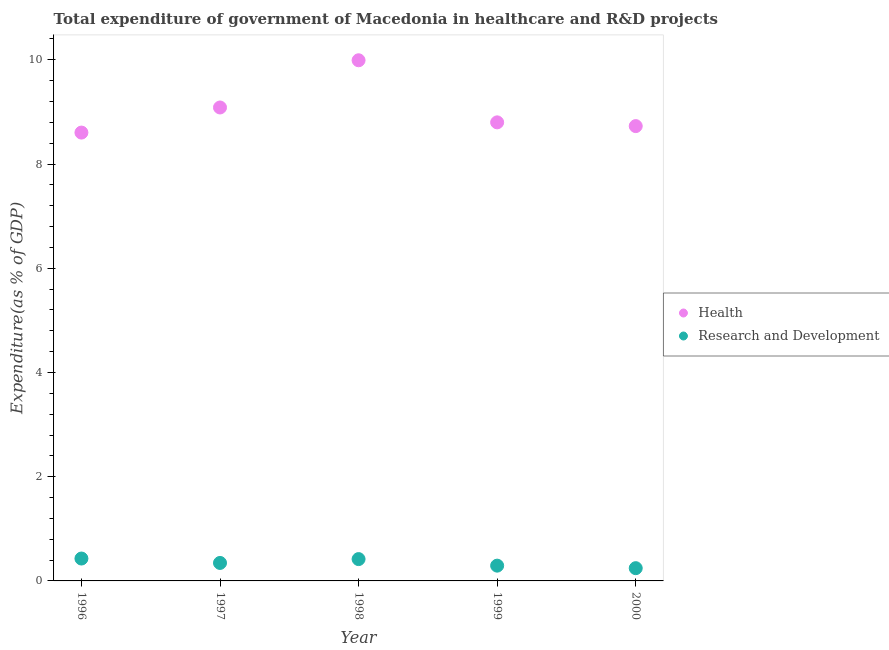How many different coloured dotlines are there?
Your answer should be compact. 2. What is the expenditure in r&d in 1999?
Give a very brief answer. 0.29. Across all years, what is the maximum expenditure in healthcare?
Your answer should be very brief. 9.99. Across all years, what is the minimum expenditure in healthcare?
Keep it short and to the point. 8.6. In which year was the expenditure in healthcare maximum?
Give a very brief answer. 1998. In which year was the expenditure in r&d minimum?
Make the answer very short. 2000. What is the total expenditure in healthcare in the graph?
Offer a terse response. 45.21. What is the difference between the expenditure in healthcare in 1997 and that in 1999?
Your response must be concise. 0.29. What is the difference between the expenditure in healthcare in 1997 and the expenditure in r&d in 1996?
Your answer should be compact. 8.66. What is the average expenditure in r&d per year?
Ensure brevity in your answer.  0.35. In the year 1996, what is the difference between the expenditure in healthcare and expenditure in r&d?
Offer a terse response. 8.17. What is the ratio of the expenditure in healthcare in 1997 to that in 1999?
Ensure brevity in your answer.  1.03. What is the difference between the highest and the second highest expenditure in r&d?
Make the answer very short. 0.01. What is the difference between the highest and the lowest expenditure in r&d?
Your answer should be compact. 0.18. In how many years, is the expenditure in r&d greater than the average expenditure in r&d taken over all years?
Your response must be concise. 2. Is the sum of the expenditure in healthcare in 1997 and 1998 greater than the maximum expenditure in r&d across all years?
Your response must be concise. Yes. Does the expenditure in r&d monotonically increase over the years?
Ensure brevity in your answer.  No. Is the expenditure in r&d strictly less than the expenditure in healthcare over the years?
Make the answer very short. Yes. How many dotlines are there?
Make the answer very short. 2. What is the difference between two consecutive major ticks on the Y-axis?
Give a very brief answer. 2. Does the graph contain any zero values?
Your answer should be very brief. No. Does the graph contain grids?
Ensure brevity in your answer.  No. How many legend labels are there?
Make the answer very short. 2. What is the title of the graph?
Keep it short and to the point. Total expenditure of government of Macedonia in healthcare and R&D projects. Does "Male entrants" appear as one of the legend labels in the graph?
Offer a terse response. No. What is the label or title of the X-axis?
Provide a short and direct response. Year. What is the label or title of the Y-axis?
Your answer should be compact. Expenditure(as % of GDP). What is the Expenditure(as % of GDP) of Health in 1996?
Your response must be concise. 8.6. What is the Expenditure(as % of GDP) in Research and Development in 1996?
Ensure brevity in your answer.  0.43. What is the Expenditure(as % of GDP) of Health in 1997?
Your answer should be very brief. 9.09. What is the Expenditure(as % of GDP) in Research and Development in 1997?
Provide a succinct answer. 0.35. What is the Expenditure(as % of GDP) of Health in 1998?
Ensure brevity in your answer.  9.99. What is the Expenditure(as % of GDP) in Research and Development in 1998?
Keep it short and to the point. 0.42. What is the Expenditure(as % of GDP) in Health in 1999?
Your answer should be very brief. 8.8. What is the Expenditure(as % of GDP) in Research and Development in 1999?
Your answer should be compact. 0.29. What is the Expenditure(as % of GDP) in Health in 2000?
Provide a succinct answer. 8.73. What is the Expenditure(as % of GDP) in Research and Development in 2000?
Ensure brevity in your answer.  0.24. Across all years, what is the maximum Expenditure(as % of GDP) of Health?
Give a very brief answer. 9.99. Across all years, what is the maximum Expenditure(as % of GDP) in Research and Development?
Offer a very short reply. 0.43. Across all years, what is the minimum Expenditure(as % of GDP) in Health?
Your answer should be very brief. 8.6. Across all years, what is the minimum Expenditure(as % of GDP) of Research and Development?
Give a very brief answer. 0.24. What is the total Expenditure(as % of GDP) in Health in the graph?
Keep it short and to the point. 45.21. What is the total Expenditure(as % of GDP) of Research and Development in the graph?
Give a very brief answer. 1.73. What is the difference between the Expenditure(as % of GDP) of Health in 1996 and that in 1997?
Make the answer very short. -0.48. What is the difference between the Expenditure(as % of GDP) in Research and Development in 1996 and that in 1997?
Ensure brevity in your answer.  0.08. What is the difference between the Expenditure(as % of GDP) in Health in 1996 and that in 1998?
Offer a terse response. -1.39. What is the difference between the Expenditure(as % of GDP) of Research and Development in 1996 and that in 1998?
Provide a short and direct response. 0.01. What is the difference between the Expenditure(as % of GDP) in Health in 1996 and that in 1999?
Offer a terse response. -0.2. What is the difference between the Expenditure(as % of GDP) of Research and Development in 1996 and that in 1999?
Your answer should be compact. 0.14. What is the difference between the Expenditure(as % of GDP) of Health in 1996 and that in 2000?
Provide a succinct answer. -0.12. What is the difference between the Expenditure(as % of GDP) of Research and Development in 1996 and that in 2000?
Offer a terse response. 0.18. What is the difference between the Expenditure(as % of GDP) of Health in 1997 and that in 1998?
Give a very brief answer. -0.91. What is the difference between the Expenditure(as % of GDP) of Research and Development in 1997 and that in 1998?
Keep it short and to the point. -0.07. What is the difference between the Expenditure(as % of GDP) of Health in 1997 and that in 1999?
Your response must be concise. 0.29. What is the difference between the Expenditure(as % of GDP) of Research and Development in 1997 and that in 1999?
Offer a very short reply. 0.05. What is the difference between the Expenditure(as % of GDP) in Health in 1997 and that in 2000?
Offer a terse response. 0.36. What is the difference between the Expenditure(as % of GDP) in Research and Development in 1997 and that in 2000?
Your answer should be very brief. 0.1. What is the difference between the Expenditure(as % of GDP) of Health in 1998 and that in 1999?
Keep it short and to the point. 1.19. What is the difference between the Expenditure(as % of GDP) of Research and Development in 1998 and that in 1999?
Provide a succinct answer. 0.13. What is the difference between the Expenditure(as % of GDP) of Health in 1998 and that in 2000?
Your response must be concise. 1.26. What is the difference between the Expenditure(as % of GDP) of Research and Development in 1998 and that in 2000?
Give a very brief answer. 0.17. What is the difference between the Expenditure(as % of GDP) of Health in 1999 and that in 2000?
Offer a very short reply. 0.07. What is the difference between the Expenditure(as % of GDP) of Research and Development in 1999 and that in 2000?
Make the answer very short. 0.05. What is the difference between the Expenditure(as % of GDP) in Health in 1996 and the Expenditure(as % of GDP) in Research and Development in 1997?
Offer a terse response. 8.26. What is the difference between the Expenditure(as % of GDP) in Health in 1996 and the Expenditure(as % of GDP) in Research and Development in 1998?
Ensure brevity in your answer.  8.18. What is the difference between the Expenditure(as % of GDP) of Health in 1996 and the Expenditure(as % of GDP) of Research and Development in 1999?
Your response must be concise. 8.31. What is the difference between the Expenditure(as % of GDP) in Health in 1996 and the Expenditure(as % of GDP) in Research and Development in 2000?
Give a very brief answer. 8.36. What is the difference between the Expenditure(as % of GDP) in Health in 1997 and the Expenditure(as % of GDP) in Research and Development in 1998?
Offer a very short reply. 8.67. What is the difference between the Expenditure(as % of GDP) in Health in 1997 and the Expenditure(as % of GDP) in Research and Development in 1999?
Give a very brief answer. 8.79. What is the difference between the Expenditure(as % of GDP) of Health in 1997 and the Expenditure(as % of GDP) of Research and Development in 2000?
Offer a very short reply. 8.84. What is the difference between the Expenditure(as % of GDP) of Health in 1998 and the Expenditure(as % of GDP) of Research and Development in 1999?
Make the answer very short. 9.7. What is the difference between the Expenditure(as % of GDP) of Health in 1998 and the Expenditure(as % of GDP) of Research and Development in 2000?
Keep it short and to the point. 9.75. What is the difference between the Expenditure(as % of GDP) in Health in 1999 and the Expenditure(as % of GDP) in Research and Development in 2000?
Ensure brevity in your answer.  8.56. What is the average Expenditure(as % of GDP) of Health per year?
Offer a terse response. 9.04. What is the average Expenditure(as % of GDP) in Research and Development per year?
Keep it short and to the point. 0.35. In the year 1996, what is the difference between the Expenditure(as % of GDP) in Health and Expenditure(as % of GDP) in Research and Development?
Ensure brevity in your answer.  8.17. In the year 1997, what is the difference between the Expenditure(as % of GDP) of Health and Expenditure(as % of GDP) of Research and Development?
Provide a short and direct response. 8.74. In the year 1998, what is the difference between the Expenditure(as % of GDP) in Health and Expenditure(as % of GDP) in Research and Development?
Your answer should be very brief. 9.57. In the year 1999, what is the difference between the Expenditure(as % of GDP) in Health and Expenditure(as % of GDP) in Research and Development?
Offer a terse response. 8.51. In the year 2000, what is the difference between the Expenditure(as % of GDP) in Health and Expenditure(as % of GDP) in Research and Development?
Your response must be concise. 8.48. What is the ratio of the Expenditure(as % of GDP) in Health in 1996 to that in 1997?
Make the answer very short. 0.95. What is the ratio of the Expenditure(as % of GDP) of Research and Development in 1996 to that in 1997?
Keep it short and to the point. 1.24. What is the ratio of the Expenditure(as % of GDP) of Health in 1996 to that in 1998?
Keep it short and to the point. 0.86. What is the ratio of the Expenditure(as % of GDP) in Research and Development in 1996 to that in 1998?
Offer a very short reply. 1.03. What is the ratio of the Expenditure(as % of GDP) of Health in 1996 to that in 1999?
Make the answer very short. 0.98. What is the ratio of the Expenditure(as % of GDP) in Research and Development in 1996 to that in 1999?
Keep it short and to the point. 1.47. What is the ratio of the Expenditure(as % of GDP) in Health in 1996 to that in 2000?
Provide a short and direct response. 0.99. What is the ratio of the Expenditure(as % of GDP) of Research and Development in 1996 to that in 2000?
Make the answer very short. 1.76. What is the ratio of the Expenditure(as % of GDP) in Health in 1997 to that in 1998?
Make the answer very short. 0.91. What is the ratio of the Expenditure(as % of GDP) of Research and Development in 1997 to that in 1998?
Provide a succinct answer. 0.82. What is the ratio of the Expenditure(as % of GDP) of Health in 1997 to that in 1999?
Your response must be concise. 1.03. What is the ratio of the Expenditure(as % of GDP) in Research and Development in 1997 to that in 1999?
Provide a short and direct response. 1.18. What is the ratio of the Expenditure(as % of GDP) of Health in 1997 to that in 2000?
Make the answer very short. 1.04. What is the ratio of the Expenditure(as % of GDP) in Research and Development in 1997 to that in 2000?
Offer a terse response. 1.41. What is the ratio of the Expenditure(as % of GDP) of Health in 1998 to that in 1999?
Your response must be concise. 1.14. What is the ratio of the Expenditure(as % of GDP) of Research and Development in 1998 to that in 1999?
Offer a very short reply. 1.43. What is the ratio of the Expenditure(as % of GDP) in Health in 1998 to that in 2000?
Your answer should be compact. 1.14. What is the ratio of the Expenditure(as % of GDP) of Research and Development in 1998 to that in 2000?
Ensure brevity in your answer.  1.71. What is the ratio of the Expenditure(as % of GDP) in Health in 1999 to that in 2000?
Make the answer very short. 1.01. What is the ratio of the Expenditure(as % of GDP) of Research and Development in 1999 to that in 2000?
Your answer should be very brief. 1.2. What is the difference between the highest and the second highest Expenditure(as % of GDP) of Health?
Make the answer very short. 0.91. What is the difference between the highest and the second highest Expenditure(as % of GDP) of Research and Development?
Ensure brevity in your answer.  0.01. What is the difference between the highest and the lowest Expenditure(as % of GDP) in Health?
Your answer should be compact. 1.39. What is the difference between the highest and the lowest Expenditure(as % of GDP) of Research and Development?
Your answer should be very brief. 0.18. 